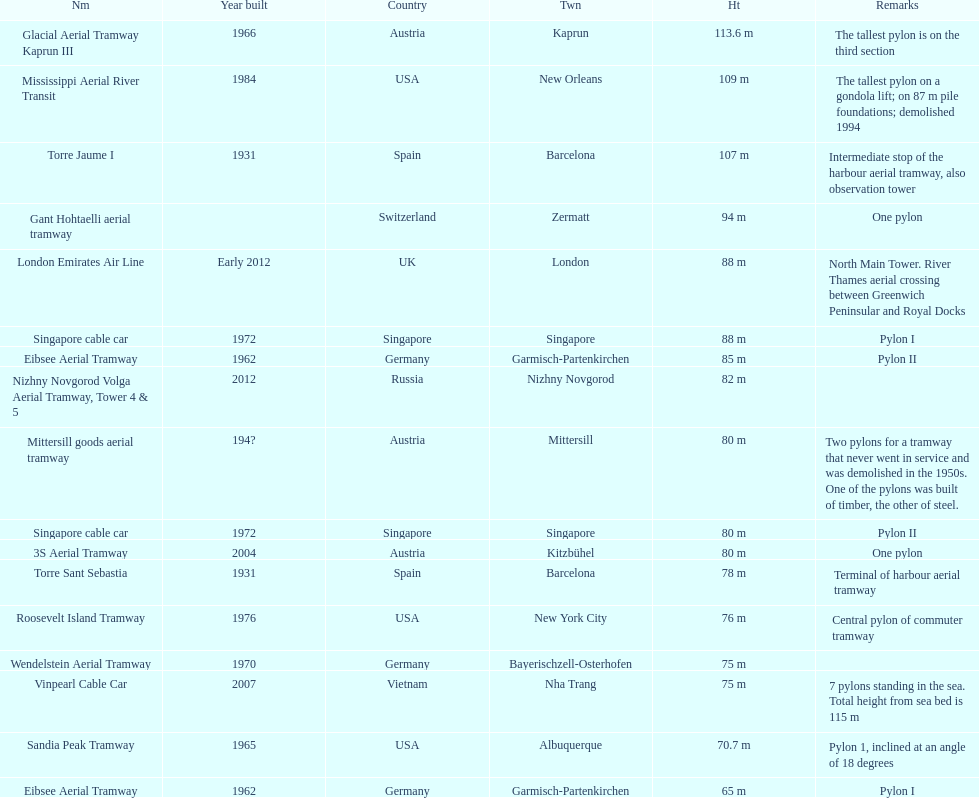Write the full table. {'header': ['Nm', 'Year built', 'Country', 'Twn', 'Ht', 'Remarks'], 'rows': [['Glacial Aerial Tramway Kaprun III', '1966', 'Austria', 'Kaprun', '113.6 m', 'The tallest pylon is on the third section'], ['Mississippi Aerial River Transit', '1984', 'USA', 'New Orleans', '109 m', 'The tallest pylon on a gondola lift; on 87 m pile foundations; demolished 1994'], ['Torre Jaume I', '1931', 'Spain', 'Barcelona', '107 m', 'Intermediate stop of the harbour aerial tramway, also observation tower'], ['Gant Hohtaelli aerial tramway', '', 'Switzerland', 'Zermatt', '94 m', 'One pylon'], ['London Emirates Air Line', 'Early 2012', 'UK', 'London', '88 m', 'North Main Tower. River Thames aerial crossing between Greenwich Peninsular and Royal Docks'], ['Singapore cable car', '1972', 'Singapore', 'Singapore', '88 m', 'Pylon I'], ['Eibsee Aerial Tramway', '1962', 'Germany', 'Garmisch-Partenkirchen', '85 m', 'Pylon II'], ['Nizhny Novgorod Volga Aerial Tramway, Tower 4 & 5', '2012', 'Russia', 'Nizhny Novgorod', '82 m', ''], ['Mittersill goods aerial tramway', '194?', 'Austria', 'Mittersill', '80 m', 'Two pylons for a tramway that never went in service and was demolished in the 1950s. One of the pylons was built of timber, the other of steel.'], ['Singapore cable car', '1972', 'Singapore', 'Singapore', '80 m', 'Pylon II'], ['3S Aerial Tramway', '2004', 'Austria', 'Kitzbühel', '80 m', 'One pylon'], ['Torre Sant Sebastia', '1931', 'Spain', 'Barcelona', '78 m', 'Terminal of harbour aerial tramway'], ['Roosevelt Island Tramway', '1976', 'USA', 'New York City', '76 m', 'Central pylon of commuter tramway'], ['Wendelstein Aerial Tramway', '1970', 'Germany', 'Bayerischzell-Osterhofen', '75 m', ''], ['Vinpearl Cable Car', '2007', 'Vietnam', 'Nha Trang', '75 m', '7 pylons standing in the sea. Total height from sea bed is 115 m'], ['Sandia Peak Tramway', '1965', 'USA', 'Albuquerque', '70.7 m', 'Pylon 1, inclined at an angle of 18 degrees'], ['Eibsee Aerial Tramway', '1962', 'Germany', 'Garmisch-Partenkirchen', '65 m', 'Pylon I']]} How many metres is the tallest pylon? 113.6 m. 